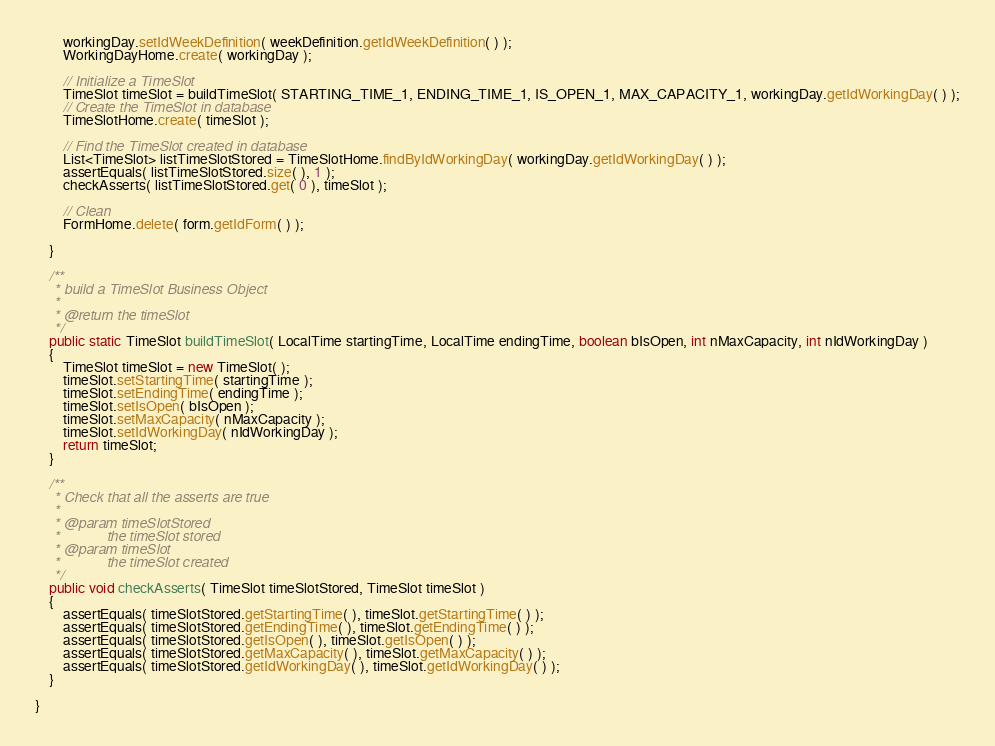Convert code to text. <code><loc_0><loc_0><loc_500><loc_500><_Java_>        workingDay.setIdWeekDefinition( weekDefinition.getIdWeekDefinition( ) );
        WorkingDayHome.create( workingDay );

        // Initialize a TimeSlot
        TimeSlot timeSlot = buildTimeSlot( STARTING_TIME_1, ENDING_TIME_1, IS_OPEN_1, MAX_CAPACITY_1, workingDay.getIdWorkingDay( ) );
        // Create the TimeSlot in database
        TimeSlotHome.create( timeSlot );

        // Find the TimeSlot created in database
        List<TimeSlot> listTimeSlotStored = TimeSlotHome.findByIdWorkingDay( workingDay.getIdWorkingDay( ) );
        assertEquals( listTimeSlotStored.size( ), 1 );
        checkAsserts( listTimeSlotStored.get( 0 ), timeSlot );

        // Clean
        FormHome.delete( form.getIdForm( ) );

    }

    /**
     * build a TimeSlot Business Object
     * 
     * @return the timeSlot
     */
    public static TimeSlot buildTimeSlot( LocalTime startingTime, LocalTime endingTime, boolean bIsOpen, int nMaxCapacity, int nIdWorkingDay )
    {
        TimeSlot timeSlot = new TimeSlot( );
        timeSlot.setStartingTime( startingTime );
        timeSlot.setEndingTime( endingTime );
        timeSlot.setIsOpen( bIsOpen );
        timeSlot.setMaxCapacity( nMaxCapacity );
        timeSlot.setIdWorkingDay( nIdWorkingDay );
        return timeSlot;
    }

    /**
     * Check that all the asserts are true
     * 
     * @param timeSlotStored
     *            the timeSlot stored
     * @param timeSlot
     *            the timeSlot created
     */
    public void checkAsserts( TimeSlot timeSlotStored, TimeSlot timeSlot )
    {
        assertEquals( timeSlotStored.getStartingTime( ), timeSlot.getStartingTime( ) );
        assertEquals( timeSlotStored.getEndingTime( ), timeSlot.getEndingTime( ) );
        assertEquals( timeSlotStored.getIsOpen( ), timeSlot.getIsOpen( ) );
        assertEquals( timeSlotStored.getMaxCapacity( ), timeSlot.getMaxCapacity( ) );
        assertEquals( timeSlotStored.getIdWorkingDay( ), timeSlot.getIdWorkingDay( ) );
    }

}
</code> 